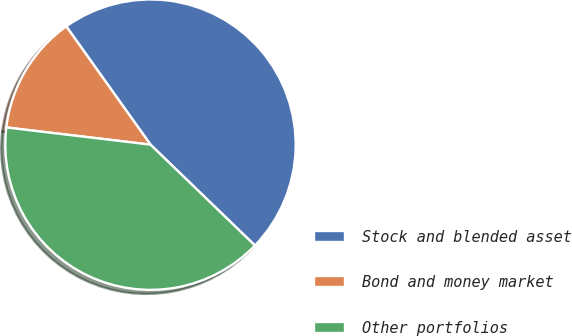Convert chart. <chart><loc_0><loc_0><loc_500><loc_500><pie_chart><fcel>Stock and blended asset<fcel>Bond and money market<fcel>Other portfolios<nl><fcel>47.07%<fcel>13.26%<fcel>39.67%<nl></chart> 